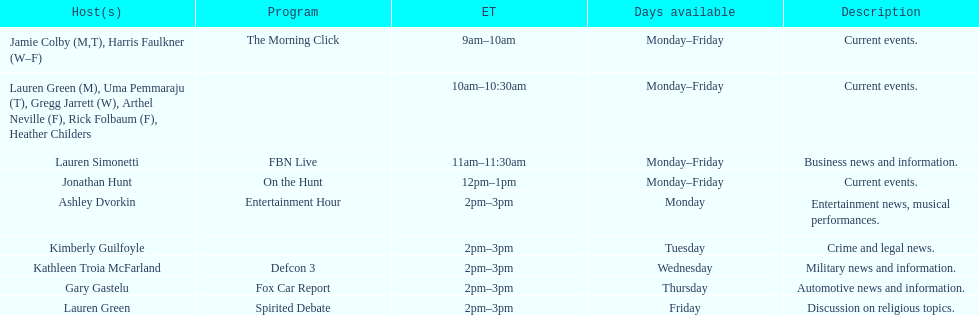How many days during the week does the show fbn live air? 5. Can you parse all the data within this table? {'header': ['Host(s)', 'Program', 'ET', 'Days available', 'Description'], 'rows': [['Jamie Colby (M,T), Harris Faulkner (W–F)', 'The Morning Click', '9am–10am', 'Monday–Friday', 'Current events.'], ['Lauren Green (M), Uma Pemmaraju (T), Gregg Jarrett (W), Arthel Neville (F), Rick Folbaum (F), Heather Childers', '', '10am–10:30am', 'Monday–Friday', 'Current events.'], ['Lauren Simonetti', 'FBN Live', '11am–11:30am', 'Monday–Friday', 'Business news and information.'], ['Jonathan Hunt', 'On the Hunt', '12pm–1pm', 'Monday–Friday', 'Current events.'], ['Ashley Dvorkin', 'Entertainment Hour', '2pm–3pm', 'Monday', 'Entertainment news, musical performances.'], ['Kimberly Guilfoyle', '', '2pm–3pm', 'Tuesday', 'Crime and legal news.'], ['Kathleen Troia McFarland', 'Defcon 3', '2pm–3pm', 'Wednesday', 'Military news and information.'], ['Gary Gastelu', 'Fox Car Report', '2pm–3pm', 'Thursday', 'Automotive news and information.'], ['Lauren Green', 'Spirited Debate', '2pm–3pm', 'Friday', 'Discussion on religious topics.']]} 